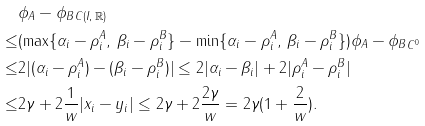Convert formula to latex. <formula><loc_0><loc_0><loc_500><loc_500>& \| \phi _ { A } - \phi _ { B } \| _ { C ( I , \, \mathbb { R } ) } \\ \leq & ( \max \{ \alpha _ { i } - \rho _ { i } ^ { A } , \, \beta _ { i } - \rho _ { i } ^ { B } \} - \min \{ \alpha _ { i } - \rho _ { i } ^ { A } , \, \beta _ { i } - \rho _ { i } ^ { B } \} ) \| \phi _ { A } - \phi _ { B } \| _ { C ^ { 0 } } \\ \leq & 2 | ( \alpha _ { i } - \rho _ { i } ^ { A } ) - ( \beta _ { i } - \rho _ { i } ^ { B } ) | \leq 2 | \alpha _ { i } - \beta _ { i } | + 2 | \rho _ { i } ^ { A } - \rho _ { i } ^ { B } | \\ \leq & 2 \gamma + 2 \frac { 1 } { w } | x _ { i } - y _ { i } | \leq 2 \gamma + 2 \frac { 2 \gamma } { w } = 2 \gamma ( 1 + \frac { 2 } { w } ) .</formula> 